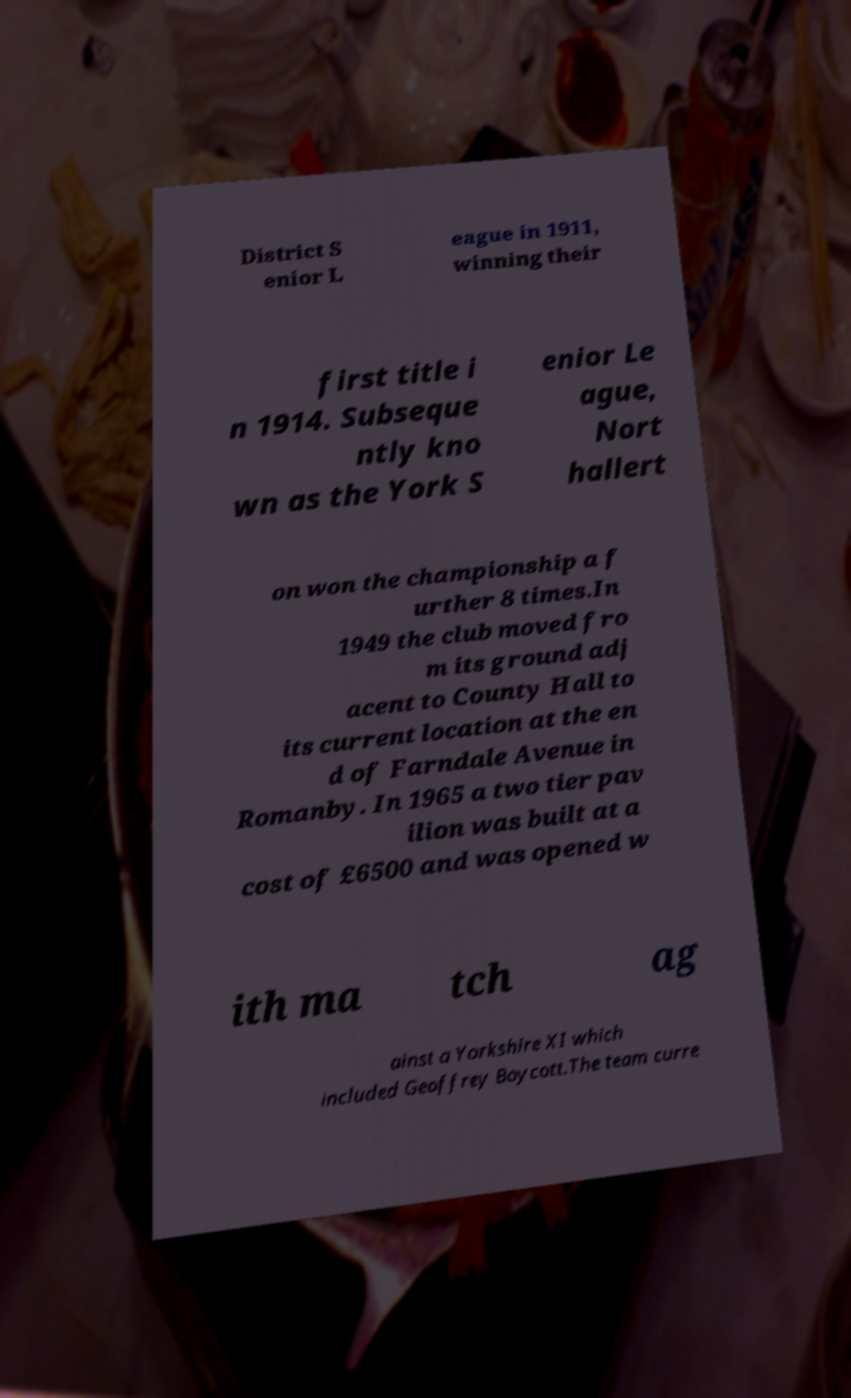There's text embedded in this image that I need extracted. Can you transcribe it verbatim? District S enior L eague in 1911, winning their first title i n 1914. Subseque ntly kno wn as the York S enior Le ague, Nort hallert on won the championship a f urther 8 times.In 1949 the club moved fro m its ground adj acent to County Hall to its current location at the en d of Farndale Avenue in Romanby. In 1965 a two tier pav ilion was built at a cost of £6500 and was opened w ith ma tch ag ainst a Yorkshire XI which included Geoffrey Boycott.The team curre 